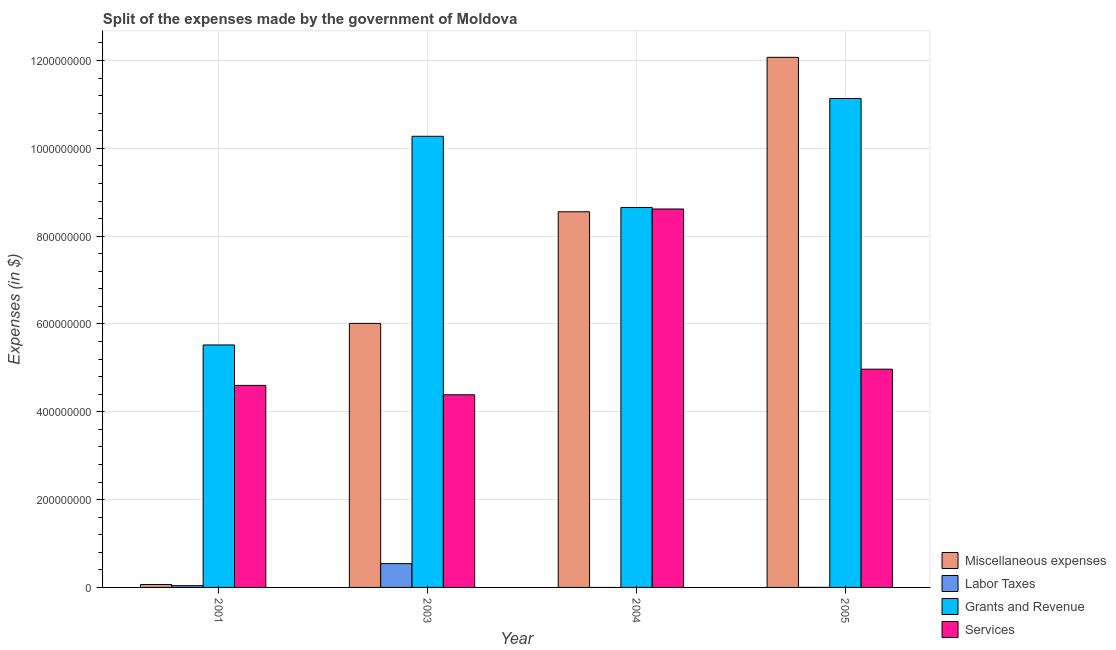How many different coloured bars are there?
Provide a short and direct response. 4. Are the number of bars per tick equal to the number of legend labels?
Offer a terse response. No. Are the number of bars on each tick of the X-axis equal?
Provide a short and direct response. No. How many bars are there on the 1st tick from the left?
Keep it short and to the point. 4. What is the label of the 2nd group of bars from the left?
Provide a short and direct response. 2003. What is the amount spent on services in 2004?
Your answer should be very brief. 8.62e+08. Across all years, what is the maximum amount spent on services?
Provide a short and direct response. 8.62e+08. Across all years, what is the minimum amount spent on grants and revenue?
Your response must be concise. 5.52e+08. What is the total amount spent on labor taxes in the graph?
Your response must be concise. 5.83e+07. What is the difference between the amount spent on miscellaneous expenses in 2001 and that in 2004?
Offer a terse response. -8.49e+08. What is the difference between the amount spent on labor taxes in 2005 and the amount spent on miscellaneous expenses in 2003?
Give a very brief answer. -5.41e+07. What is the average amount spent on grants and revenue per year?
Your response must be concise. 8.90e+08. In the year 2001, what is the difference between the amount spent on grants and revenue and amount spent on labor taxes?
Ensure brevity in your answer.  0. In how many years, is the amount spent on services greater than 80000000 $?
Offer a terse response. 4. What is the ratio of the amount spent on labor taxes in 2003 to that in 2005?
Keep it short and to the point. 542. Is the difference between the amount spent on grants and revenue in 2001 and 2004 greater than the difference between the amount spent on services in 2001 and 2004?
Your answer should be very brief. No. What is the difference between the highest and the second highest amount spent on grants and revenue?
Your answer should be compact. 8.61e+07. What is the difference between the highest and the lowest amount spent on services?
Your response must be concise. 4.23e+08. Is the sum of the amount spent on services in 2003 and 2004 greater than the maximum amount spent on miscellaneous expenses across all years?
Keep it short and to the point. Yes. Is it the case that in every year, the sum of the amount spent on labor taxes and amount spent on grants and revenue is greater than the sum of amount spent on services and amount spent on miscellaneous expenses?
Provide a succinct answer. No. How many bars are there?
Your answer should be very brief. 15. How many years are there in the graph?
Provide a succinct answer. 4. Does the graph contain any zero values?
Your response must be concise. Yes. How are the legend labels stacked?
Your answer should be compact. Vertical. What is the title of the graph?
Make the answer very short. Split of the expenses made by the government of Moldova. What is the label or title of the Y-axis?
Your answer should be compact. Expenses (in $). What is the Expenses (in $) of Miscellaneous expenses in 2001?
Make the answer very short. 6.60e+06. What is the Expenses (in $) in Labor Taxes in 2001?
Provide a succinct answer. 4.00e+06. What is the Expenses (in $) in Grants and Revenue in 2001?
Your answer should be compact. 5.52e+08. What is the Expenses (in $) in Services in 2001?
Give a very brief answer. 4.60e+08. What is the Expenses (in $) in Miscellaneous expenses in 2003?
Offer a terse response. 6.01e+08. What is the Expenses (in $) in Labor Taxes in 2003?
Offer a terse response. 5.42e+07. What is the Expenses (in $) of Grants and Revenue in 2003?
Your response must be concise. 1.03e+09. What is the Expenses (in $) of Services in 2003?
Your answer should be very brief. 4.39e+08. What is the Expenses (in $) of Miscellaneous expenses in 2004?
Give a very brief answer. 8.56e+08. What is the Expenses (in $) in Grants and Revenue in 2004?
Make the answer very short. 8.65e+08. What is the Expenses (in $) in Services in 2004?
Provide a succinct answer. 8.62e+08. What is the Expenses (in $) in Miscellaneous expenses in 2005?
Keep it short and to the point. 1.21e+09. What is the Expenses (in $) of Grants and Revenue in 2005?
Offer a terse response. 1.11e+09. What is the Expenses (in $) of Services in 2005?
Your answer should be compact. 4.97e+08. Across all years, what is the maximum Expenses (in $) of Miscellaneous expenses?
Ensure brevity in your answer.  1.21e+09. Across all years, what is the maximum Expenses (in $) of Labor Taxes?
Your answer should be compact. 5.42e+07. Across all years, what is the maximum Expenses (in $) in Grants and Revenue?
Provide a succinct answer. 1.11e+09. Across all years, what is the maximum Expenses (in $) of Services?
Ensure brevity in your answer.  8.62e+08. Across all years, what is the minimum Expenses (in $) in Miscellaneous expenses?
Make the answer very short. 6.60e+06. Across all years, what is the minimum Expenses (in $) in Grants and Revenue?
Keep it short and to the point. 5.52e+08. Across all years, what is the minimum Expenses (in $) in Services?
Offer a terse response. 4.39e+08. What is the total Expenses (in $) of Miscellaneous expenses in the graph?
Offer a terse response. 2.67e+09. What is the total Expenses (in $) of Labor Taxes in the graph?
Provide a short and direct response. 5.83e+07. What is the total Expenses (in $) of Grants and Revenue in the graph?
Make the answer very short. 3.56e+09. What is the total Expenses (in $) in Services in the graph?
Your answer should be compact. 2.26e+09. What is the difference between the Expenses (in $) of Miscellaneous expenses in 2001 and that in 2003?
Your response must be concise. -5.95e+08. What is the difference between the Expenses (in $) of Labor Taxes in 2001 and that in 2003?
Your answer should be compact. -5.02e+07. What is the difference between the Expenses (in $) in Grants and Revenue in 2001 and that in 2003?
Your answer should be very brief. -4.75e+08. What is the difference between the Expenses (in $) in Services in 2001 and that in 2003?
Your answer should be very brief. 2.14e+07. What is the difference between the Expenses (in $) in Miscellaneous expenses in 2001 and that in 2004?
Ensure brevity in your answer.  -8.49e+08. What is the difference between the Expenses (in $) in Grants and Revenue in 2001 and that in 2004?
Your answer should be compact. -3.13e+08. What is the difference between the Expenses (in $) in Services in 2001 and that in 2004?
Your response must be concise. -4.02e+08. What is the difference between the Expenses (in $) of Miscellaneous expenses in 2001 and that in 2005?
Offer a terse response. -1.20e+09. What is the difference between the Expenses (in $) of Labor Taxes in 2001 and that in 2005?
Your answer should be compact. 3.90e+06. What is the difference between the Expenses (in $) of Grants and Revenue in 2001 and that in 2005?
Make the answer very short. -5.61e+08. What is the difference between the Expenses (in $) in Services in 2001 and that in 2005?
Offer a terse response. -3.69e+07. What is the difference between the Expenses (in $) of Miscellaneous expenses in 2003 and that in 2004?
Keep it short and to the point. -2.54e+08. What is the difference between the Expenses (in $) of Grants and Revenue in 2003 and that in 2004?
Your answer should be very brief. 1.62e+08. What is the difference between the Expenses (in $) of Services in 2003 and that in 2004?
Your answer should be very brief. -4.23e+08. What is the difference between the Expenses (in $) of Miscellaneous expenses in 2003 and that in 2005?
Provide a short and direct response. -6.06e+08. What is the difference between the Expenses (in $) in Labor Taxes in 2003 and that in 2005?
Offer a very short reply. 5.41e+07. What is the difference between the Expenses (in $) of Grants and Revenue in 2003 and that in 2005?
Your answer should be compact. -8.61e+07. What is the difference between the Expenses (in $) of Services in 2003 and that in 2005?
Ensure brevity in your answer.  -5.83e+07. What is the difference between the Expenses (in $) of Miscellaneous expenses in 2004 and that in 2005?
Provide a succinct answer. -3.52e+08. What is the difference between the Expenses (in $) of Grants and Revenue in 2004 and that in 2005?
Offer a very short reply. -2.48e+08. What is the difference between the Expenses (in $) in Services in 2004 and that in 2005?
Offer a very short reply. 3.65e+08. What is the difference between the Expenses (in $) of Miscellaneous expenses in 2001 and the Expenses (in $) of Labor Taxes in 2003?
Make the answer very short. -4.76e+07. What is the difference between the Expenses (in $) in Miscellaneous expenses in 2001 and the Expenses (in $) in Grants and Revenue in 2003?
Make the answer very short. -1.02e+09. What is the difference between the Expenses (in $) in Miscellaneous expenses in 2001 and the Expenses (in $) in Services in 2003?
Your answer should be compact. -4.32e+08. What is the difference between the Expenses (in $) of Labor Taxes in 2001 and the Expenses (in $) of Grants and Revenue in 2003?
Offer a very short reply. -1.02e+09. What is the difference between the Expenses (in $) in Labor Taxes in 2001 and the Expenses (in $) in Services in 2003?
Your response must be concise. -4.35e+08. What is the difference between the Expenses (in $) of Grants and Revenue in 2001 and the Expenses (in $) of Services in 2003?
Ensure brevity in your answer.  1.14e+08. What is the difference between the Expenses (in $) of Miscellaneous expenses in 2001 and the Expenses (in $) of Grants and Revenue in 2004?
Offer a very short reply. -8.59e+08. What is the difference between the Expenses (in $) in Miscellaneous expenses in 2001 and the Expenses (in $) in Services in 2004?
Make the answer very short. -8.55e+08. What is the difference between the Expenses (in $) of Labor Taxes in 2001 and the Expenses (in $) of Grants and Revenue in 2004?
Your response must be concise. -8.61e+08. What is the difference between the Expenses (in $) in Labor Taxes in 2001 and the Expenses (in $) in Services in 2004?
Make the answer very short. -8.58e+08. What is the difference between the Expenses (in $) of Grants and Revenue in 2001 and the Expenses (in $) of Services in 2004?
Offer a terse response. -3.10e+08. What is the difference between the Expenses (in $) of Miscellaneous expenses in 2001 and the Expenses (in $) of Labor Taxes in 2005?
Make the answer very short. 6.50e+06. What is the difference between the Expenses (in $) of Miscellaneous expenses in 2001 and the Expenses (in $) of Grants and Revenue in 2005?
Ensure brevity in your answer.  -1.11e+09. What is the difference between the Expenses (in $) in Miscellaneous expenses in 2001 and the Expenses (in $) in Services in 2005?
Make the answer very short. -4.90e+08. What is the difference between the Expenses (in $) of Labor Taxes in 2001 and the Expenses (in $) of Grants and Revenue in 2005?
Your answer should be very brief. -1.11e+09. What is the difference between the Expenses (in $) of Labor Taxes in 2001 and the Expenses (in $) of Services in 2005?
Keep it short and to the point. -4.93e+08. What is the difference between the Expenses (in $) of Grants and Revenue in 2001 and the Expenses (in $) of Services in 2005?
Your response must be concise. 5.52e+07. What is the difference between the Expenses (in $) in Miscellaneous expenses in 2003 and the Expenses (in $) in Grants and Revenue in 2004?
Provide a succinct answer. -2.64e+08. What is the difference between the Expenses (in $) in Miscellaneous expenses in 2003 and the Expenses (in $) in Services in 2004?
Ensure brevity in your answer.  -2.60e+08. What is the difference between the Expenses (in $) in Labor Taxes in 2003 and the Expenses (in $) in Grants and Revenue in 2004?
Make the answer very short. -8.11e+08. What is the difference between the Expenses (in $) of Labor Taxes in 2003 and the Expenses (in $) of Services in 2004?
Provide a short and direct response. -8.08e+08. What is the difference between the Expenses (in $) of Grants and Revenue in 2003 and the Expenses (in $) of Services in 2004?
Your response must be concise. 1.66e+08. What is the difference between the Expenses (in $) in Miscellaneous expenses in 2003 and the Expenses (in $) in Labor Taxes in 2005?
Keep it short and to the point. 6.01e+08. What is the difference between the Expenses (in $) in Miscellaneous expenses in 2003 and the Expenses (in $) in Grants and Revenue in 2005?
Provide a succinct answer. -5.12e+08. What is the difference between the Expenses (in $) of Miscellaneous expenses in 2003 and the Expenses (in $) of Services in 2005?
Ensure brevity in your answer.  1.04e+08. What is the difference between the Expenses (in $) of Labor Taxes in 2003 and the Expenses (in $) of Grants and Revenue in 2005?
Provide a short and direct response. -1.06e+09. What is the difference between the Expenses (in $) of Labor Taxes in 2003 and the Expenses (in $) of Services in 2005?
Your response must be concise. -4.43e+08. What is the difference between the Expenses (in $) in Grants and Revenue in 2003 and the Expenses (in $) in Services in 2005?
Provide a short and direct response. 5.30e+08. What is the difference between the Expenses (in $) of Miscellaneous expenses in 2004 and the Expenses (in $) of Labor Taxes in 2005?
Your answer should be compact. 8.55e+08. What is the difference between the Expenses (in $) in Miscellaneous expenses in 2004 and the Expenses (in $) in Grants and Revenue in 2005?
Provide a succinct answer. -2.58e+08. What is the difference between the Expenses (in $) in Miscellaneous expenses in 2004 and the Expenses (in $) in Services in 2005?
Keep it short and to the point. 3.58e+08. What is the difference between the Expenses (in $) in Grants and Revenue in 2004 and the Expenses (in $) in Services in 2005?
Offer a terse response. 3.68e+08. What is the average Expenses (in $) of Miscellaneous expenses per year?
Offer a very short reply. 6.68e+08. What is the average Expenses (in $) of Labor Taxes per year?
Give a very brief answer. 1.46e+07. What is the average Expenses (in $) of Grants and Revenue per year?
Offer a very short reply. 8.90e+08. What is the average Expenses (in $) of Services per year?
Your response must be concise. 5.64e+08. In the year 2001, what is the difference between the Expenses (in $) of Miscellaneous expenses and Expenses (in $) of Labor Taxes?
Offer a terse response. 2.60e+06. In the year 2001, what is the difference between the Expenses (in $) of Miscellaneous expenses and Expenses (in $) of Grants and Revenue?
Provide a short and direct response. -5.46e+08. In the year 2001, what is the difference between the Expenses (in $) of Miscellaneous expenses and Expenses (in $) of Services?
Provide a succinct answer. -4.54e+08. In the year 2001, what is the difference between the Expenses (in $) of Labor Taxes and Expenses (in $) of Grants and Revenue?
Provide a short and direct response. -5.48e+08. In the year 2001, what is the difference between the Expenses (in $) in Labor Taxes and Expenses (in $) in Services?
Provide a short and direct response. -4.56e+08. In the year 2001, what is the difference between the Expenses (in $) of Grants and Revenue and Expenses (in $) of Services?
Provide a short and direct response. 9.21e+07. In the year 2003, what is the difference between the Expenses (in $) in Miscellaneous expenses and Expenses (in $) in Labor Taxes?
Your answer should be compact. 5.47e+08. In the year 2003, what is the difference between the Expenses (in $) in Miscellaneous expenses and Expenses (in $) in Grants and Revenue?
Offer a terse response. -4.26e+08. In the year 2003, what is the difference between the Expenses (in $) of Miscellaneous expenses and Expenses (in $) of Services?
Offer a terse response. 1.63e+08. In the year 2003, what is the difference between the Expenses (in $) in Labor Taxes and Expenses (in $) in Grants and Revenue?
Offer a very short reply. -9.73e+08. In the year 2003, what is the difference between the Expenses (in $) in Labor Taxes and Expenses (in $) in Services?
Offer a very short reply. -3.84e+08. In the year 2003, what is the difference between the Expenses (in $) in Grants and Revenue and Expenses (in $) in Services?
Offer a very short reply. 5.89e+08. In the year 2004, what is the difference between the Expenses (in $) of Miscellaneous expenses and Expenses (in $) of Grants and Revenue?
Offer a very short reply. -9.80e+06. In the year 2004, what is the difference between the Expenses (in $) in Miscellaneous expenses and Expenses (in $) in Services?
Provide a short and direct response. -6.30e+06. In the year 2004, what is the difference between the Expenses (in $) in Grants and Revenue and Expenses (in $) in Services?
Offer a terse response. 3.50e+06. In the year 2005, what is the difference between the Expenses (in $) of Miscellaneous expenses and Expenses (in $) of Labor Taxes?
Provide a short and direct response. 1.21e+09. In the year 2005, what is the difference between the Expenses (in $) of Miscellaneous expenses and Expenses (in $) of Grants and Revenue?
Ensure brevity in your answer.  9.37e+07. In the year 2005, what is the difference between the Expenses (in $) in Miscellaneous expenses and Expenses (in $) in Services?
Ensure brevity in your answer.  7.10e+08. In the year 2005, what is the difference between the Expenses (in $) of Labor Taxes and Expenses (in $) of Grants and Revenue?
Your answer should be compact. -1.11e+09. In the year 2005, what is the difference between the Expenses (in $) in Labor Taxes and Expenses (in $) in Services?
Ensure brevity in your answer.  -4.97e+08. In the year 2005, what is the difference between the Expenses (in $) in Grants and Revenue and Expenses (in $) in Services?
Provide a succinct answer. 6.16e+08. What is the ratio of the Expenses (in $) of Miscellaneous expenses in 2001 to that in 2003?
Your answer should be very brief. 0.01. What is the ratio of the Expenses (in $) in Labor Taxes in 2001 to that in 2003?
Make the answer very short. 0.07. What is the ratio of the Expenses (in $) in Grants and Revenue in 2001 to that in 2003?
Provide a succinct answer. 0.54. What is the ratio of the Expenses (in $) in Services in 2001 to that in 2003?
Give a very brief answer. 1.05. What is the ratio of the Expenses (in $) of Miscellaneous expenses in 2001 to that in 2004?
Make the answer very short. 0.01. What is the ratio of the Expenses (in $) of Grants and Revenue in 2001 to that in 2004?
Keep it short and to the point. 0.64. What is the ratio of the Expenses (in $) in Services in 2001 to that in 2004?
Ensure brevity in your answer.  0.53. What is the ratio of the Expenses (in $) in Miscellaneous expenses in 2001 to that in 2005?
Offer a very short reply. 0.01. What is the ratio of the Expenses (in $) of Labor Taxes in 2001 to that in 2005?
Your answer should be compact. 40. What is the ratio of the Expenses (in $) of Grants and Revenue in 2001 to that in 2005?
Your answer should be very brief. 0.5. What is the ratio of the Expenses (in $) of Services in 2001 to that in 2005?
Make the answer very short. 0.93. What is the ratio of the Expenses (in $) in Miscellaneous expenses in 2003 to that in 2004?
Make the answer very short. 0.7. What is the ratio of the Expenses (in $) of Grants and Revenue in 2003 to that in 2004?
Provide a succinct answer. 1.19. What is the ratio of the Expenses (in $) in Services in 2003 to that in 2004?
Offer a very short reply. 0.51. What is the ratio of the Expenses (in $) in Miscellaneous expenses in 2003 to that in 2005?
Give a very brief answer. 0.5. What is the ratio of the Expenses (in $) in Labor Taxes in 2003 to that in 2005?
Provide a short and direct response. 542. What is the ratio of the Expenses (in $) of Grants and Revenue in 2003 to that in 2005?
Your answer should be very brief. 0.92. What is the ratio of the Expenses (in $) of Services in 2003 to that in 2005?
Your answer should be very brief. 0.88. What is the ratio of the Expenses (in $) in Miscellaneous expenses in 2004 to that in 2005?
Provide a succinct answer. 0.71. What is the ratio of the Expenses (in $) in Grants and Revenue in 2004 to that in 2005?
Ensure brevity in your answer.  0.78. What is the ratio of the Expenses (in $) in Services in 2004 to that in 2005?
Provide a succinct answer. 1.73. What is the difference between the highest and the second highest Expenses (in $) in Miscellaneous expenses?
Provide a succinct answer. 3.52e+08. What is the difference between the highest and the second highest Expenses (in $) of Labor Taxes?
Offer a very short reply. 5.02e+07. What is the difference between the highest and the second highest Expenses (in $) in Grants and Revenue?
Provide a short and direct response. 8.61e+07. What is the difference between the highest and the second highest Expenses (in $) in Services?
Offer a terse response. 3.65e+08. What is the difference between the highest and the lowest Expenses (in $) of Miscellaneous expenses?
Give a very brief answer. 1.20e+09. What is the difference between the highest and the lowest Expenses (in $) in Labor Taxes?
Provide a succinct answer. 5.42e+07. What is the difference between the highest and the lowest Expenses (in $) in Grants and Revenue?
Your response must be concise. 5.61e+08. What is the difference between the highest and the lowest Expenses (in $) of Services?
Make the answer very short. 4.23e+08. 